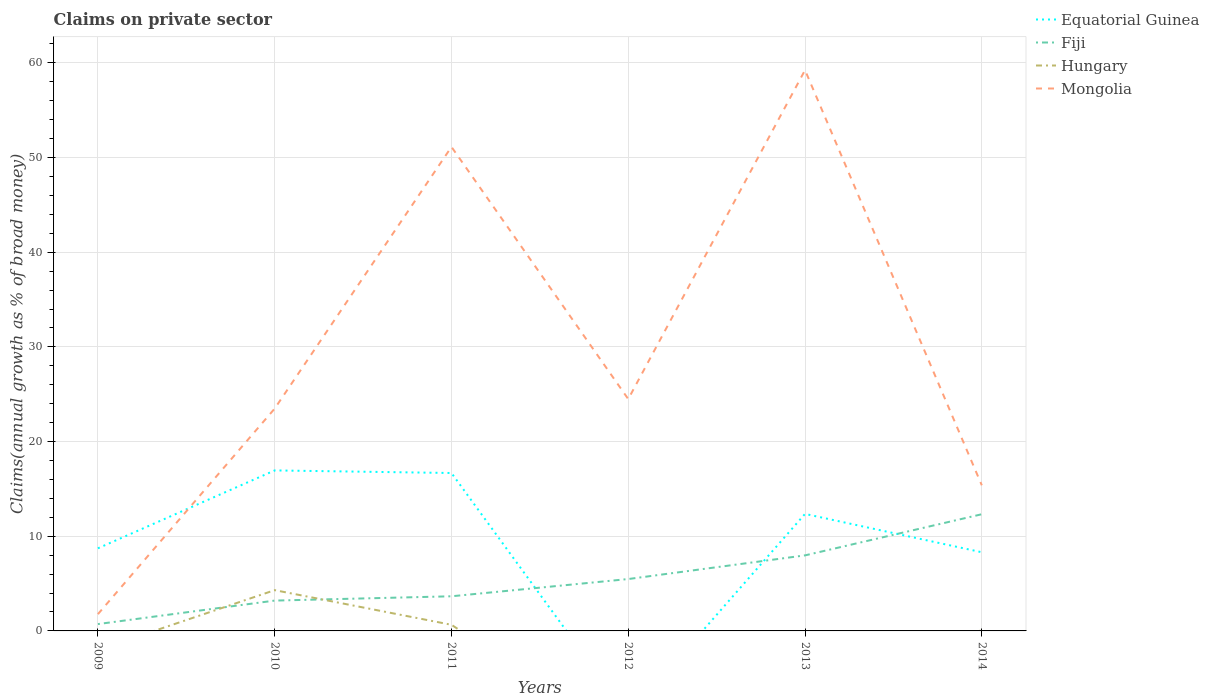How many different coloured lines are there?
Your answer should be very brief. 4. Does the line corresponding to Equatorial Guinea intersect with the line corresponding to Fiji?
Provide a succinct answer. Yes. Across all years, what is the maximum percentage of broad money claimed on private sector in Equatorial Guinea?
Keep it short and to the point. 0. What is the total percentage of broad money claimed on private sector in Mongolia in the graph?
Keep it short and to the point. -22.72. What is the difference between the highest and the second highest percentage of broad money claimed on private sector in Equatorial Guinea?
Offer a very short reply. 16.95. How many years are there in the graph?
Your response must be concise. 6. What is the difference between two consecutive major ticks on the Y-axis?
Make the answer very short. 10. Are the values on the major ticks of Y-axis written in scientific E-notation?
Ensure brevity in your answer.  No. Does the graph contain grids?
Provide a short and direct response. Yes. Where does the legend appear in the graph?
Offer a terse response. Top right. What is the title of the graph?
Your answer should be very brief. Claims on private sector. What is the label or title of the Y-axis?
Offer a very short reply. Claims(annual growth as % of broad money). What is the Claims(annual growth as % of broad money) of Equatorial Guinea in 2009?
Give a very brief answer. 8.73. What is the Claims(annual growth as % of broad money) in Fiji in 2009?
Your response must be concise. 0.72. What is the Claims(annual growth as % of broad money) in Mongolia in 2009?
Your response must be concise. 1.77. What is the Claims(annual growth as % of broad money) of Equatorial Guinea in 2010?
Your answer should be compact. 16.95. What is the Claims(annual growth as % of broad money) in Fiji in 2010?
Your answer should be compact. 3.2. What is the Claims(annual growth as % of broad money) in Hungary in 2010?
Make the answer very short. 4.31. What is the Claims(annual growth as % of broad money) in Mongolia in 2010?
Keep it short and to the point. 23.49. What is the Claims(annual growth as % of broad money) in Equatorial Guinea in 2011?
Offer a very short reply. 16.68. What is the Claims(annual growth as % of broad money) in Fiji in 2011?
Give a very brief answer. 3.66. What is the Claims(annual growth as % of broad money) in Hungary in 2011?
Give a very brief answer. 0.65. What is the Claims(annual growth as % of broad money) in Mongolia in 2011?
Provide a short and direct response. 51.13. What is the Claims(annual growth as % of broad money) of Fiji in 2012?
Ensure brevity in your answer.  5.48. What is the Claims(annual growth as % of broad money) of Hungary in 2012?
Offer a terse response. 0. What is the Claims(annual growth as % of broad money) of Mongolia in 2012?
Give a very brief answer. 24.49. What is the Claims(annual growth as % of broad money) of Equatorial Guinea in 2013?
Your answer should be compact. 12.36. What is the Claims(annual growth as % of broad money) of Fiji in 2013?
Provide a succinct answer. 7.98. What is the Claims(annual growth as % of broad money) in Hungary in 2013?
Offer a very short reply. 0. What is the Claims(annual growth as % of broad money) in Mongolia in 2013?
Offer a terse response. 59.24. What is the Claims(annual growth as % of broad money) of Equatorial Guinea in 2014?
Your answer should be compact. 8.31. What is the Claims(annual growth as % of broad money) of Fiji in 2014?
Provide a short and direct response. 12.33. What is the Claims(annual growth as % of broad money) of Hungary in 2014?
Your answer should be compact. 0.05. What is the Claims(annual growth as % of broad money) of Mongolia in 2014?
Ensure brevity in your answer.  15.38. Across all years, what is the maximum Claims(annual growth as % of broad money) in Equatorial Guinea?
Your answer should be compact. 16.95. Across all years, what is the maximum Claims(annual growth as % of broad money) in Fiji?
Make the answer very short. 12.33. Across all years, what is the maximum Claims(annual growth as % of broad money) in Hungary?
Your response must be concise. 4.31. Across all years, what is the maximum Claims(annual growth as % of broad money) of Mongolia?
Provide a succinct answer. 59.24. Across all years, what is the minimum Claims(annual growth as % of broad money) of Equatorial Guinea?
Offer a very short reply. 0. Across all years, what is the minimum Claims(annual growth as % of broad money) of Fiji?
Keep it short and to the point. 0.72. Across all years, what is the minimum Claims(annual growth as % of broad money) of Mongolia?
Provide a succinct answer. 1.77. What is the total Claims(annual growth as % of broad money) in Equatorial Guinea in the graph?
Provide a succinct answer. 63.03. What is the total Claims(annual growth as % of broad money) in Fiji in the graph?
Make the answer very short. 33.37. What is the total Claims(annual growth as % of broad money) of Hungary in the graph?
Give a very brief answer. 5. What is the total Claims(annual growth as % of broad money) of Mongolia in the graph?
Ensure brevity in your answer.  175.5. What is the difference between the Claims(annual growth as % of broad money) of Equatorial Guinea in 2009 and that in 2010?
Keep it short and to the point. -8.23. What is the difference between the Claims(annual growth as % of broad money) of Fiji in 2009 and that in 2010?
Give a very brief answer. -2.48. What is the difference between the Claims(annual growth as % of broad money) of Mongolia in 2009 and that in 2010?
Make the answer very short. -21.72. What is the difference between the Claims(annual growth as % of broad money) of Equatorial Guinea in 2009 and that in 2011?
Keep it short and to the point. -7.96. What is the difference between the Claims(annual growth as % of broad money) in Fiji in 2009 and that in 2011?
Give a very brief answer. -2.94. What is the difference between the Claims(annual growth as % of broad money) in Mongolia in 2009 and that in 2011?
Make the answer very short. -49.36. What is the difference between the Claims(annual growth as % of broad money) of Fiji in 2009 and that in 2012?
Keep it short and to the point. -4.76. What is the difference between the Claims(annual growth as % of broad money) in Mongolia in 2009 and that in 2012?
Provide a short and direct response. -22.72. What is the difference between the Claims(annual growth as % of broad money) of Equatorial Guinea in 2009 and that in 2013?
Ensure brevity in your answer.  -3.63. What is the difference between the Claims(annual growth as % of broad money) of Fiji in 2009 and that in 2013?
Your response must be concise. -7.26. What is the difference between the Claims(annual growth as % of broad money) of Mongolia in 2009 and that in 2013?
Give a very brief answer. -57.47. What is the difference between the Claims(annual growth as % of broad money) of Equatorial Guinea in 2009 and that in 2014?
Keep it short and to the point. 0.42. What is the difference between the Claims(annual growth as % of broad money) of Fiji in 2009 and that in 2014?
Ensure brevity in your answer.  -11.6. What is the difference between the Claims(annual growth as % of broad money) in Mongolia in 2009 and that in 2014?
Ensure brevity in your answer.  -13.61. What is the difference between the Claims(annual growth as % of broad money) in Equatorial Guinea in 2010 and that in 2011?
Give a very brief answer. 0.27. What is the difference between the Claims(annual growth as % of broad money) of Fiji in 2010 and that in 2011?
Offer a very short reply. -0.46. What is the difference between the Claims(annual growth as % of broad money) in Hungary in 2010 and that in 2011?
Ensure brevity in your answer.  3.66. What is the difference between the Claims(annual growth as % of broad money) in Mongolia in 2010 and that in 2011?
Your answer should be compact. -27.64. What is the difference between the Claims(annual growth as % of broad money) in Fiji in 2010 and that in 2012?
Offer a very short reply. -2.28. What is the difference between the Claims(annual growth as % of broad money) of Mongolia in 2010 and that in 2012?
Offer a very short reply. -1. What is the difference between the Claims(annual growth as % of broad money) of Equatorial Guinea in 2010 and that in 2013?
Offer a terse response. 4.59. What is the difference between the Claims(annual growth as % of broad money) in Fiji in 2010 and that in 2013?
Your answer should be very brief. -4.78. What is the difference between the Claims(annual growth as % of broad money) in Mongolia in 2010 and that in 2013?
Provide a short and direct response. -35.75. What is the difference between the Claims(annual growth as % of broad money) in Equatorial Guinea in 2010 and that in 2014?
Give a very brief answer. 8.64. What is the difference between the Claims(annual growth as % of broad money) in Fiji in 2010 and that in 2014?
Offer a very short reply. -9.12. What is the difference between the Claims(annual growth as % of broad money) of Hungary in 2010 and that in 2014?
Your response must be concise. 4.26. What is the difference between the Claims(annual growth as % of broad money) of Mongolia in 2010 and that in 2014?
Give a very brief answer. 8.1. What is the difference between the Claims(annual growth as % of broad money) in Fiji in 2011 and that in 2012?
Your answer should be compact. -1.82. What is the difference between the Claims(annual growth as % of broad money) of Mongolia in 2011 and that in 2012?
Keep it short and to the point. 26.64. What is the difference between the Claims(annual growth as % of broad money) of Equatorial Guinea in 2011 and that in 2013?
Make the answer very short. 4.32. What is the difference between the Claims(annual growth as % of broad money) in Fiji in 2011 and that in 2013?
Keep it short and to the point. -4.32. What is the difference between the Claims(annual growth as % of broad money) in Mongolia in 2011 and that in 2013?
Keep it short and to the point. -8.11. What is the difference between the Claims(annual growth as % of broad money) in Equatorial Guinea in 2011 and that in 2014?
Provide a short and direct response. 8.37. What is the difference between the Claims(annual growth as % of broad money) of Fiji in 2011 and that in 2014?
Provide a succinct answer. -8.67. What is the difference between the Claims(annual growth as % of broad money) in Hungary in 2011 and that in 2014?
Ensure brevity in your answer.  0.6. What is the difference between the Claims(annual growth as % of broad money) in Mongolia in 2011 and that in 2014?
Give a very brief answer. 35.75. What is the difference between the Claims(annual growth as % of broad money) in Fiji in 2012 and that in 2013?
Make the answer very short. -2.5. What is the difference between the Claims(annual growth as % of broad money) in Mongolia in 2012 and that in 2013?
Give a very brief answer. -34.75. What is the difference between the Claims(annual growth as % of broad money) of Fiji in 2012 and that in 2014?
Give a very brief answer. -6.85. What is the difference between the Claims(annual growth as % of broad money) in Mongolia in 2012 and that in 2014?
Give a very brief answer. 9.11. What is the difference between the Claims(annual growth as % of broad money) of Equatorial Guinea in 2013 and that in 2014?
Your answer should be very brief. 4.05. What is the difference between the Claims(annual growth as % of broad money) in Fiji in 2013 and that in 2014?
Make the answer very short. -4.35. What is the difference between the Claims(annual growth as % of broad money) in Mongolia in 2013 and that in 2014?
Your answer should be compact. 43.86. What is the difference between the Claims(annual growth as % of broad money) in Equatorial Guinea in 2009 and the Claims(annual growth as % of broad money) in Fiji in 2010?
Your answer should be very brief. 5.52. What is the difference between the Claims(annual growth as % of broad money) of Equatorial Guinea in 2009 and the Claims(annual growth as % of broad money) of Hungary in 2010?
Provide a short and direct response. 4.42. What is the difference between the Claims(annual growth as % of broad money) in Equatorial Guinea in 2009 and the Claims(annual growth as % of broad money) in Mongolia in 2010?
Provide a succinct answer. -14.76. What is the difference between the Claims(annual growth as % of broad money) of Fiji in 2009 and the Claims(annual growth as % of broad money) of Hungary in 2010?
Make the answer very short. -3.58. What is the difference between the Claims(annual growth as % of broad money) in Fiji in 2009 and the Claims(annual growth as % of broad money) in Mongolia in 2010?
Your answer should be very brief. -22.76. What is the difference between the Claims(annual growth as % of broad money) in Equatorial Guinea in 2009 and the Claims(annual growth as % of broad money) in Fiji in 2011?
Offer a very short reply. 5.07. What is the difference between the Claims(annual growth as % of broad money) in Equatorial Guinea in 2009 and the Claims(annual growth as % of broad money) in Hungary in 2011?
Provide a short and direct response. 8.08. What is the difference between the Claims(annual growth as % of broad money) in Equatorial Guinea in 2009 and the Claims(annual growth as % of broad money) in Mongolia in 2011?
Give a very brief answer. -42.4. What is the difference between the Claims(annual growth as % of broad money) in Fiji in 2009 and the Claims(annual growth as % of broad money) in Hungary in 2011?
Your answer should be very brief. 0.07. What is the difference between the Claims(annual growth as % of broad money) in Fiji in 2009 and the Claims(annual growth as % of broad money) in Mongolia in 2011?
Ensure brevity in your answer.  -50.41. What is the difference between the Claims(annual growth as % of broad money) of Equatorial Guinea in 2009 and the Claims(annual growth as % of broad money) of Fiji in 2012?
Your response must be concise. 3.25. What is the difference between the Claims(annual growth as % of broad money) of Equatorial Guinea in 2009 and the Claims(annual growth as % of broad money) of Mongolia in 2012?
Provide a succinct answer. -15.77. What is the difference between the Claims(annual growth as % of broad money) of Fiji in 2009 and the Claims(annual growth as % of broad money) of Mongolia in 2012?
Give a very brief answer. -23.77. What is the difference between the Claims(annual growth as % of broad money) of Equatorial Guinea in 2009 and the Claims(annual growth as % of broad money) of Fiji in 2013?
Your answer should be compact. 0.75. What is the difference between the Claims(annual growth as % of broad money) of Equatorial Guinea in 2009 and the Claims(annual growth as % of broad money) of Mongolia in 2013?
Provide a succinct answer. -50.51. What is the difference between the Claims(annual growth as % of broad money) in Fiji in 2009 and the Claims(annual growth as % of broad money) in Mongolia in 2013?
Offer a very short reply. -58.51. What is the difference between the Claims(annual growth as % of broad money) in Equatorial Guinea in 2009 and the Claims(annual growth as % of broad money) in Fiji in 2014?
Your answer should be compact. -3.6. What is the difference between the Claims(annual growth as % of broad money) of Equatorial Guinea in 2009 and the Claims(annual growth as % of broad money) of Hungary in 2014?
Offer a terse response. 8.68. What is the difference between the Claims(annual growth as % of broad money) of Equatorial Guinea in 2009 and the Claims(annual growth as % of broad money) of Mongolia in 2014?
Offer a very short reply. -6.66. What is the difference between the Claims(annual growth as % of broad money) of Fiji in 2009 and the Claims(annual growth as % of broad money) of Hungary in 2014?
Offer a very short reply. 0.68. What is the difference between the Claims(annual growth as % of broad money) of Fiji in 2009 and the Claims(annual growth as % of broad money) of Mongolia in 2014?
Give a very brief answer. -14.66. What is the difference between the Claims(annual growth as % of broad money) of Equatorial Guinea in 2010 and the Claims(annual growth as % of broad money) of Fiji in 2011?
Make the answer very short. 13.29. What is the difference between the Claims(annual growth as % of broad money) of Equatorial Guinea in 2010 and the Claims(annual growth as % of broad money) of Hungary in 2011?
Offer a very short reply. 16.31. What is the difference between the Claims(annual growth as % of broad money) of Equatorial Guinea in 2010 and the Claims(annual growth as % of broad money) of Mongolia in 2011?
Ensure brevity in your answer.  -34.18. What is the difference between the Claims(annual growth as % of broad money) of Fiji in 2010 and the Claims(annual growth as % of broad money) of Hungary in 2011?
Your response must be concise. 2.56. What is the difference between the Claims(annual growth as % of broad money) in Fiji in 2010 and the Claims(annual growth as % of broad money) in Mongolia in 2011?
Offer a terse response. -47.93. What is the difference between the Claims(annual growth as % of broad money) of Hungary in 2010 and the Claims(annual growth as % of broad money) of Mongolia in 2011?
Offer a very short reply. -46.82. What is the difference between the Claims(annual growth as % of broad money) in Equatorial Guinea in 2010 and the Claims(annual growth as % of broad money) in Fiji in 2012?
Provide a succinct answer. 11.47. What is the difference between the Claims(annual growth as % of broad money) of Equatorial Guinea in 2010 and the Claims(annual growth as % of broad money) of Mongolia in 2012?
Offer a terse response. -7.54. What is the difference between the Claims(annual growth as % of broad money) in Fiji in 2010 and the Claims(annual growth as % of broad money) in Mongolia in 2012?
Offer a very short reply. -21.29. What is the difference between the Claims(annual growth as % of broad money) of Hungary in 2010 and the Claims(annual growth as % of broad money) of Mongolia in 2012?
Provide a succinct answer. -20.18. What is the difference between the Claims(annual growth as % of broad money) of Equatorial Guinea in 2010 and the Claims(annual growth as % of broad money) of Fiji in 2013?
Make the answer very short. 8.97. What is the difference between the Claims(annual growth as % of broad money) of Equatorial Guinea in 2010 and the Claims(annual growth as % of broad money) of Mongolia in 2013?
Your response must be concise. -42.28. What is the difference between the Claims(annual growth as % of broad money) of Fiji in 2010 and the Claims(annual growth as % of broad money) of Mongolia in 2013?
Your response must be concise. -56.03. What is the difference between the Claims(annual growth as % of broad money) of Hungary in 2010 and the Claims(annual growth as % of broad money) of Mongolia in 2013?
Give a very brief answer. -54.93. What is the difference between the Claims(annual growth as % of broad money) in Equatorial Guinea in 2010 and the Claims(annual growth as % of broad money) in Fiji in 2014?
Your answer should be compact. 4.63. What is the difference between the Claims(annual growth as % of broad money) in Equatorial Guinea in 2010 and the Claims(annual growth as % of broad money) in Hungary in 2014?
Provide a succinct answer. 16.91. What is the difference between the Claims(annual growth as % of broad money) of Equatorial Guinea in 2010 and the Claims(annual growth as % of broad money) of Mongolia in 2014?
Offer a terse response. 1.57. What is the difference between the Claims(annual growth as % of broad money) in Fiji in 2010 and the Claims(annual growth as % of broad money) in Hungary in 2014?
Provide a succinct answer. 3.16. What is the difference between the Claims(annual growth as % of broad money) of Fiji in 2010 and the Claims(annual growth as % of broad money) of Mongolia in 2014?
Ensure brevity in your answer.  -12.18. What is the difference between the Claims(annual growth as % of broad money) in Hungary in 2010 and the Claims(annual growth as % of broad money) in Mongolia in 2014?
Your answer should be compact. -11.07. What is the difference between the Claims(annual growth as % of broad money) in Equatorial Guinea in 2011 and the Claims(annual growth as % of broad money) in Fiji in 2012?
Provide a succinct answer. 11.2. What is the difference between the Claims(annual growth as % of broad money) in Equatorial Guinea in 2011 and the Claims(annual growth as % of broad money) in Mongolia in 2012?
Provide a short and direct response. -7.81. What is the difference between the Claims(annual growth as % of broad money) of Fiji in 2011 and the Claims(annual growth as % of broad money) of Mongolia in 2012?
Provide a succinct answer. -20.83. What is the difference between the Claims(annual growth as % of broad money) in Hungary in 2011 and the Claims(annual growth as % of broad money) in Mongolia in 2012?
Offer a very short reply. -23.84. What is the difference between the Claims(annual growth as % of broad money) of Equatorial Guinea in 2011 and the Claims(annual growth as % of broad money) of Fiji in 2013?
Offer a very short reply. 8.7. What is the difference between the Claims(annual growth as % of broad money) in Equatorial Guinea in 2011 and the Claims(annual growth as % of broad money) in Mongolia in 2013?
Offer a very short reply. -42.56. What is the difference between the Claims(annual growth as % of broad money) in Fiji in 2011 and the Claims(annual growth as % of broad money) in Mongolia in 2013?
Your response must be concise. -55.58. What is the difference between the Claims(annual growth as % of broad money) of Hungary in 2011 and the Claims(annual growth as % of broad money) of Mongolia in 2013?
Ensure brevity in your answer.  -58.59. What is the difference between the Claims(annual growth as % of broad money) of Equatorial Guinea in 2011 and the Claims(annual growth as % of broad money) of Fiji in 2014?
Offer a very short reply. 4.35. What is the difference between the Claims(annual growth as % of broad money) in Equatorial Guinea in 2011 and the Claims(annual growth as % of broad money) in Hungary in 2014?
Offer a terse response. 16.63. What is the difference between the Claims(annual growth as % of broad money) of Equatorial Guinea in 2011 and the Claims(annual growth as % of broad money) of Mongolia in 2014?
Ensure brevity in your answer.  1.3. What is the difference between the Claims(annual growth as % of broad money) of Fiji in 2011 and the Claims(annual growth as % of broad money) of Hungary in 2014?
Keep it short and to the point. 3.61. What is the difference between the Claims(annual growth as % of broad money) of Fiji in 2011 and the Claims(annual growth as % of broad money) of Mongolia in 2014?
Ensure brevity in your answer.  -11.72. What is the difference between the Claims(annual growth as % of broad money) in Hungary in 2011 and the Claims(annual growth as % of broad money) in Mongolia in 2014?
Keep it short and to the point. -14.73. What is the difference between the Claims(annual growth as % of broad money) in Fiji in 2012 and the Claims(annual growth as % of broad money) in Mongolia in 2013?
Give a very brief answer. -53.76. What is the difference between the Claims(annual growth as % of broad money) in Fiji in 2012 and the Claims(annual growth as % of broad money) in Hungary in 2014?
Your response must be concise. 5.43. What is the difference between the Claims(annual growth as % of broad money) in Fiji in 2012 and the Claims(annual growth as % of broad money) in Mongolia in 2014?
Provide a short and direct response. -9.9. What is the difference between the Claims(annual growth as % of broad money) of Equatorial Guinea in 2013 and the Claims(annual growth as % of broad money) of Fiji in 2014?
Keep it short and to the point. 0.03. What is the difference between the Claims(annual growth as % of broad money) in Equatorial Guinea in 2013 and the Claims(annual growth as % of broad money) in Hungary in 2014?
Provide a succinct answer. 12.31. What is the difference between the Claims(annual growth as % of broad money) of Equatorial Guinea in 2013 and the Claims(annual growth as % of broad money) of Mongolia in 2014?
Your answer should be very brief. -3.02. What is the difference between the Claims(annual growth as % of broad money) in Fiji in 2013 and the Claims(annual growth as % of broad money) in Hungary in 2014?
Make the answer very short. 7.93. What is the difference between the Claims(annual growth as % of broad money) of Fiji in 2013 and the Claims(annual growth as % of broad money) of Mongolia in 2014?
Your response must be concise. -7.4. What is the average Claims(annual growth as % of broad money) in Equatorial Guinea per year?
Your answer should be compact. 10.51. What is the average Claims(annual growth as % of broad money) of Fiji per year?
Your answer should be compact. 5.56. What is the average Claims(annual growth as % of broad money) of Hungary per year?
Ensure brevity in your answer.  0.83. What is the average Claims(annual growth as % of broad money) in Mongolia per year?
Offer a terse response. 29.25. In the year 2009, what is the difference between the Claims(annual growth as % of broad money) in Equatorial Guinea and Claims(annual growth as % of broad money) in Fiji?
Provide a succinct answer. 8. In the year 2009, what is the difference between the Claims(annual growth as % of broad money) in Equatorial Guinea and Claims(annual growth as % of broad money) in Mongolia?
Keep it short and to the point. 6.95. In the year 2009, what is the difference between the Claims(annual growth as % of broad money) of Fiji and Claims(annual growth as % of broad money) of Mongolia?
Provide a succinct answer. -1.05. In the year 2010, what is the difference between the Claims(annual growth as % of broad money) in Equatorial Guinea and Claims(annual growth as % of broad money) in Fiji?
Ensure brevity in your answer.  13.75. In the year 2010, what is the difference between the Claims(annual growth as % of broad money) of Equatorial Guinea and Claims(annual growth as % of broad money) of Hungary?
Keep it short and to the point. 12.65. In the year 2010, what is the difference between the Claims(annual growth as % of broad money) of Equatorial Guinea and Claims(annual growth as % of broad money) of Mongolia?
Provide a short and direct response. -6.53. In the year 2010, what is the difference between the Claims(annual growth as % of broad money) of Fiji and Claims(annual growth as % of broad money) of Hungary?
Provide a succinct answer. -1.1. In the year 2010, what is the difference between the Claims(annual growth as % of broad money) in Fiji and Claims(annual growth as % of broad money) in Mongolia?
Make the answer very short. -20.28. In the year 2010, what is the difference between the Claims(annual growth as % of broad money) in Hungary and Claims(annual growth as % of broad money) in Mongolia?
Keep it short and to the point. -19.18. In the year 2011, what is the difference between the Claims(annual growth as % of broad money) of Equatorial Guinea and Claims(annual growth as % of broad money) of Fiji?
Your response must be concise. 13.02. In the year 2011, what is the difference between the Claims(annual growth as % of broad money) of Equatorial Guinea and Claims(annual growth as % of broad money) of Hungary?
Your response must be concise. 16.03. In the year 2011, what is the difference between the Claims(annual growth as % of broad money) of Equatorial Guinea and Claims(annual growth as % of broad money) of Mongolia?
Offer a very short reply. -34.45. In the year 2011, what is the difference between the Claims(annual growth as % of broad money) of Fiji and Claims(annual growth as % of broad money) of Hungary?
Provide a short and direct response. 3.01. In the year 2011, what is the difference between the Claims(annual growth as % of broad money) of Fiji and Claims(annual growth as % of broad money) of Mongolia?
Offer a very short reply. -47.47. In the year 2011, what is the difference between the Claims(annual growth as % of broad money) of Hungary and Claims(annual growth as % of broad money) of Mongolia?
Provide a short and direct response. -50.48. In the year 2012, what is the difference between the Claims(annual growth as % of broad money) of Fiji and Claims(annual growth as % of broad money) of Mongolia?
Provide a short and direct response. -19.01. In the year 2013, what is the difference between the Claims(annual growth as % of broad money) of Equatorial Guinea and Claims(annual growth as % of broad money) of Fiji?
Provide a succinct answer. 4.38. In the year 2013, what is the difference between the Claims(annual growth as % of broad money) in Equatorial Guinea and Claims(annual growth as % of broad money) in Mongolia?
Provide a short and direct response. -46.88. In the year 2013, what is the difference between the Claims(annual growth as % of broad money) in Fiji and Claims(annual growth as % of broad money) in Mongolia?
Provide a succinct answer. -51.26. In the year 2014, what is the difference between the Claims(annual growth as % of broad money) of Equatorial Guinea and Claims(annual growth as % of broad money) of Fiji?
Offer a terse response. -4.02. In the year 2014, what is the difference between the Claims(annual growth as % of broad money) in Equatorial Guinea and Claims(annual growth as % of broad money) in Hungary?
Give a very brief answer. 8.26. In the year 2014, what is the difference between the Claims(annual growth as % of broad money) in Equatorial Guinea and Claims(annual growth as % of broad money) in Mongolia?
Your answer should be very brief. -7.07. In the year 2014, what is the difference between the Claims(annual growth as % of broad money) in Fiji and Claims(annual growth as % of broad money) in Hungary?
Offer a terse response. 12.28. In the year 2014, what is the difference between the Claims(annual growth as % of broad money) of Fiji and Claims(annual growth as % of broad money) of Mongolia?
Your response must be concise. -3.06. In the year 2014, what is the difference between the Claims(annual growth as % of broad money) in Hungary and Claims(annual growth as % of broad money) in Mongolia?
Make the answer very short. -15.33. What is the ratio of the Claims(annual growth as % of broad money) in Equatorial Guinea in 2009 to that in 2010?
Provide a short and direct response. 0.51. What is the ratio of the Claims(annual growth as % of broad money) of Fiji in 2009 to that in 2010?
Your answer should be compact. 0.23. What is the ratio of the Claims(annual growth as % of broad money) of Mongolia in 2009 to that in 2010?
Make the answer very short. 0.08. What is the ratio of the Claims(annual growth as % of broad money) in Equatorial Guinea in 2009 to that in 2011?
Ensure brevity in your answer.  0.52. What is the ratio of the Claims(annual growth as % of broad money) of Fiji in 2009 to that in 2011?
Your answer should be very brief. 0.2. What is the ratio of the Claims(annual growth as % of broad money) of Mongolia in 2009 to that in 2011?
Provide a succinct answer. 0.03. What is the ratio of the Claims(annual growth as % of broad money) of Fiji in 2009 to that in 2012?
Offer a very short reply. 0.13. What is the ratio of the Claims(annual growth as % of broad money) of Mongolia in 2009 to that in 2012?
Offer a terse response. 0.07. What is the ratio of the Claims(annual growth as % of broad money) of Equatorial Guinea in 2009 to that in 2013?
Keep it short and to the point. 0.71. What is the ratio of the Claims(annual growth as % of broad money) in Fiji in 2009 to that in 2013?
Offer a terse response. 0.09. What is the ratio of the Claims(annual growth as % of broad money) of Mongolia in 2009 to that in 2013?
Your answer should be very brief. 0.03. What is the ratio of the Claims(annual growth as % of broad money) of Fiji in 2009 to that in 2014?
Ensure brevity in your answer.  0.06. What is the ratio of the Claims(annual growth as % of broad money) in Mongolia in 2009 to that in 2014?
Your answer should be compact. 0.12. What is the ratio of the Claims(annual growth as % of broad money) in Equatorial Guinea in 2010 to that in 2011?
Your answer should be compact. 1.02. What is the ratio of the Claims(annual growth as % of broad money) of Fiji in 2010 to that in 2011?
Provide a succinct answer. 0.88. What is the ratio of the Claims(annual growth as % of broad money) of Hungary in 2010 to that in 2011?
Your answer should be very brief. 6.65. What is the ratio of the Claims(annual growth as % of broad money) of Mongolia in 2010 to that in 2011?
Your answer should be compact. 0.46. What is the ratio of the Claims(annual growth as % of broad money) in Fiji in 2010 to that in 2012?
Your answer should be very brief. 0.58. What is the ratio of the Claims(annual growth as % of broad money) of Mongolia in 2010 to that in 2012?
Provide a short and direct response. 0.96. What is the ratio of the Claims(annual growth as % of broad money) of Equatorial Guinea in 2010 to that in 2013?
Your answer should be compact. 1.37. What is the ratio of the Claims(annual growth as % of broad money) in Fiji in 2010 to that in 2013?
Your response must be concise. 0.4. What is the ratio of the Claims(annual growth as % of broad money) of Mongolia in 2010 to that in 2013?
Your answer should be compact. 0.4. What is the ratio of the Claims(annual growth as % of broad money) in Equatorial Guinea in 2010 to that in 2014?
Offer a terse response. 2.04. What is the ratio of the Claims(annual growth as % of broad money) of Fiji in 2010 to that in 2014?
Your answer should be compact. 0.26. What is the ratio of the Claims(annual growth as % of broad money) of Hungary in 2010 to that in 2014?
Provide a succinct answer. 91.03. What is the ratio of the Claims(annual growth as % of broad money) in Mongolia in 2010 to that in 2014?
Offer a terse response. 1.53. What is the ratio of the Claims(annual growth as % of broad money) in Fiji in 2011 to that in 2012?
Give a very brief answer. 0.67. What is the ratio of the Claims(annual growth as % of broad money) in Mongolia in 2011 to that in 2012?
Keep it short and to the point. 2.09. What is the ratio of the Claims(annual growth as % of broad money) in Equatorial Guinea in 2011 to that in 2013?
Ensure brevity in your answer.  1.35. What is the ratio of the Claims(annual growth as % of broad money) in Fiji in 2011 to that in 2013?
Make the answer very short. 0.46. What is the ratio of the Claims(annual growth as % of broad money) of Mongolia in 2011 to that in 2013?
Your answer should be very brief. 0.86. What is the ratio of the Claims(annual growth as % of broad money) in Equatorial Guinea in 2011 to that in 2014?
Give a very brief answer. 2.01. What is the ratio of the Claims(annual growth as % of broad money) of Fiji in 2011 to that in 2014?
Provide a succinct answer. 0.3. What is the ratio of the Claims(annual growth as % of broad money) of Hungary in 2011 to that in 2014?
Your answer should be very brief. 13.7. What is the ratio of the Claims(annual growth as % of broad money) of Mongolia in 2011 to that in 2014?
Your answer should be compact. 3.32. What is the ratio of the Claims(annual growth as % of broad money) of Fiji in 2012 to that in 2013?
Give a very brief answer. 0.69. What is the ratio of the Claims(annual growth as % of broad money) of Mongolia in 2012 to that in 2013?
Your response must be concise. 0.41. What is the ratio of the Claims(annual growth as % of broad money) in Fiji in 2012 to that in 2014?
Your answer should be compact. 0.44. What is the ratio of the Claims(annual growth as % of broad money) of Mongolia in 2012 to that in 2014?
Provide a short and direct response. 1.59. What is the ratio of the Claims(annual growth as % of broad money) of Equatorial Guinea in 2013 to that in 2014?
Keep it short and to the point. 1.49. What is the ratio of the Claims(annual growth as % of broad money) of Fiji in 2013 to that in 2014?
Offer a terse response. 0.65. What is the ratio of the Claims(annual growth as % of broad money) of Mongolia in 2013 to that in 2014?
Provide a short and direct response. 3.85. What is the difference between the highest and the second highest Claims(annual growth as % of broad money) in Equatorial Guinea?
Your answer should be very brief. 0.27. What is the difference between the highest and the second highest Claims(annual growth as % of broad money) of Fiji?
Your answer should be very brief. 4.35. What is the difference between the highest and the second highest Claims(annual growth as % of broad money) of Hungary?
Ensure brevity in your answer.  3.66. What is the difference between the highest and the second highest Claims(annual growth as % of broad money) of Mongolia?
Provide a short and direct response. 8.11. What is the difference between the highest and the lowest Claims(annual growth as % of broad money) of Equatorial Guinea?
Ensure brevity in your answer.  16.95. What is the difference between the highest and the lowest Claims(annual growth as % of broad money) in Fiji?
Your response must be concise. 11.6. What is the difference between the highest and the lowest Claims(annual growth as % of broad money) of Hungary?
Offer a terse response. 4.31. What is the difference between the highest and the lowest Claims(annual growth as % of broad money) in Mongolia?
Ensure brevity in your answer.  57.47. 